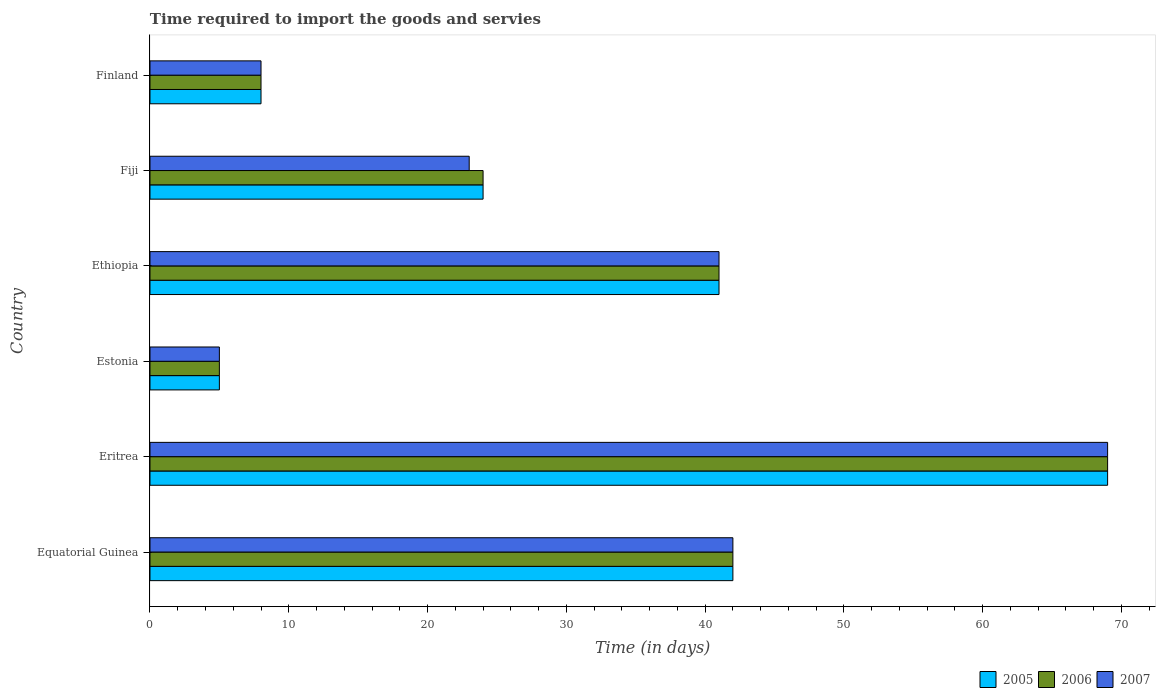How many different coloured bars are there?
Give a very brief answer. 3. Are the number of bars on each tick of the Y-axis equal?
Make the answer very short. Yes. How many bars are there on the 2nd tick from the top?
Your response must be concise. 3. What is the label of the 5th group of bars from the top?
Your answer should be very brief. Eritrea. In how many cases, is the number of bars for a given country not equal to the number of legend labels?
Offer a very short reply. 0. Across all countries, what is the maximum number of days required to import the goods and services in 2005?
Make the answer very short. 69. In which country was the number of days required to import the goods and services in 2005 maximum?
Provide a short and direct response. Eritrea. In which country was the number of days required to import the goods and services in 2006 minimum?
Offer a terse response. Estonia. What is the total number of days required to import the goods and services in 2005 in the graph?
Your answer should be very brief. 189. What is the difference between the number of days required to import the goods and services in 2006 in Equatorial Guinea and that in Estonia?
Ensure brevity in your answer.  37. What is the average number of days required to import the goods and services in 2007 per country?
Offer a terse response. 31.33. In how many countries, is the number of days required to import the goods and services in 2006 greater than 28 days?
Provide a short and direct response. 3. What is the ratio of the number of days required to import the goods and services in 2007 in Estonia to that in Ethiopia?
Make the answer very short. 0.12. Is the difference between the number of days required to import the goods and services in 2006 in Fiji and Finland greater than the difference between the number of days required to import the goods and services in 2005 in Fiji and Finland?
Your answer should be compact. No. What is the difference between the highest and the lowest number of days required to import the goods and services in 2005?
Your response must be concise. 64. In how many countries, is the number of days required to import the goods and services in 2005 greater than the average number of days required to import the goods and services in 2005 taken over all countries?
Ensure brevity in your answer.  3. Is the sum of the number of days required to import the goods and services in 2006 in Eritrea and Estonia greater than the maximum number of days required to import the goods and services in 2007 across all countries?
Provide a short and direct response. Yes. Are all the bars in the graph horizontal?
Your answer should be very brief. Yes. How many countries are there in the graph?
Offer a very short reply. 6. Are the values on the major ticks of X-axis written in scientific E-notation?
Give a very brief answer. No. How many legend labels are there?
Make the answer very short. 3. What is the title of the graph?
Make the answer very short. Time required to import the goods and servies. Does "1987" appear as one of the legend labels in the graph?
Ensure brevity in your answer.  No. What is the label or title of the X-axis?
Your answer should be very brief. Time (in days). What is the label or title of the Y-axis?
Keep it short and to the point. Country. What is the Time (in days) in 2005 in Equatorial Guinea?
Your response must be concise. 42. What is the Time (in days) in 2005 in Eritrea?
Offer a terse response. 69. What is the Time (in days) in 2007 in Eritrea?
Your answer should be very brief. 69. What is the Time (in days) in 2006 in Estonia?
Your response must be concise. 5. What is the Time (in days) in 2007 in Estonia?
Your response must be concise. 5. What is the Time (in days) in 2005 in Ethiopia?
Give a very brief answer. 41. What is the Time (in days) of 2005 in Fiji?
Provide a short and direct response. 24. What is the Time (in days) in 2006 in Fiji?
Offer a terse response. 24. What is the Time (in days) of 2007 in Fiji?
Make the answer very short. 23. What is the Time (in days) in 2005 in Finland?
Your response must be concise. 8. What is the Time (in days) in 2006 in Finland?
Your response must be concise. 8. What is the Time (in days) of 2007 in Finland?
Make the answer very short. 8. Across all countries, what is the maximum Time (in days) in 2005?
Make the answer very short. 69. Across all countries, what is the minimum Time (in days) in 2005?
Offer a terse response. 5. What is the total Time (in days) of 2005 in the graph?
Give a very brief answer. 189. What is the total Time (in days) in 2006 in the graph?
Make the answer very short. 189. What is the total Time (in days) of 2007 in the graph?
Provide a succinct answer. 188. What is the difference between the Time (in days) of 2006 in Equatorial Guinea and that in Eritrea?
Provide a succinct answer. -27. What is the difference between the Time (in days) of 2007 in Equatorial Guinea and that in Eritrea?
Make the answer very short. -27. What is the difference between the Time (in days) in 2005 in Equatorial Guinea and that in Estonia?
Give a very brief answer. 37. What is the difference between the Time (in days) of 2006 in Equatorial Guinea and that in Estonia?
Give a very brief answer. 37. What is the difference between the Time (in days) of 2005 in Equatorial Guinea and that in Finland?
Offer a terse response. 34. What is the difference between the Time (in days) in 2006 in Equatorial Guinea and that in Finland?
Ensure brevity in your answer.  34. What is the difference between the Time (in days) in 2007 in Equatorial Guinea and that in Finland?
Provide a succinct answer. 34. What is the difference between the Time (in days) in 2005 in Eritrea and that in Estonia?
Provide a short and direct response. 64. What is the difference between the Time (in days) of 2006 in Eritrea and that in Estonia?
Offer a terse response. 64. What is the difference between the Time (in days) in 2005 in Eritrea and that in Ethiopia?
Your response must be concise. 28. What is the difference between the Time (in days) of 2007 in Eritrea and that in Ethiopia?
Provide a succinct answer. 28. What is the difference between the Time (in days) in 2005 in Eritrea and that in Fiji?
Keep it short and to the point. 45. What is the difference between the Time (in days) of 2007 in Eritrea and that in Fiji?
Offer a terse response. 46. What is the difference between the Time (in days) of 2007 in Eritrea and that in Finland?
Your answer should be very brief. 61. What is the difference between the Time (in days) in 2005 in Estonia and that in Ethiopia?
Keep it short and to the point. -36. What is the difference between the Time (in days) of 2006 in Estonia and that in Ethiopia?
Make the answer very short. -36. What is the difference between the Time (in days) in 2007 in Estonia and that in Ethiopia?
Ensure brevity in your answer.  -36. What is the difference between the Time (in days) of 2005 in Estonia and that in Fiji?
Offer a terse response. -19. What is the difference between the Time (in days) in 2006 in Estonia and that in Fiji?
Your response must be concise. -19. What is the difference between the Time (in days) in 2007 in Estonia and that in Fiji?
Provide a short and direct response. -18. What is the difference between the Time (in days) of 2005 in Ethiopia and that in Fiji?
Your answer should be very brief. 17. What is the difference between the Time (in days) in 2006 in Ethiopia and that in Fiji?
Your answer should be very brief. 17. What is the difference between the Time (in days) of 2006 in Fiji and that in Finland?
Make the answer very short. 16. What is the difference between the Time (in days) of 2007 in Fiji and that in Finland?
Give a very brief answer. 15. What is the difference between the Time (in days) of 2006 in Equatorial Guinea and the Time (in days) of 2007 in Eritrea?
Provide a succinct answer. -27. What is the difference between the Time (in days) in 2005 in Equatorial Guinea and the Time (in days) in 2006 in Estonia?
Offer a very short reply. 37. What is the difference between the Time (in days) of 2005 in Equatorial Guinea and the Time (in days) of 2007 in Estonia?
Make the answer very short. 37. What is the difference between the Time (in days) in 2006 in Equatorial Guinea and the Time (in days) in 2007 in Estonia?
Keep it short and to the point. 37. What is the difference between the Time (in days) in 2005 in Equatorial Guinea and the Time (in days) in 2006 in Ethiopia?
Keep it short and to the point. 1. What is the difference between the Time (in days) of 2005 in Equatorial Guinea and the Time (in days) of 2007 in Fiji?
Ensure brevity in your answer.  19. What is the difference between the Time (in days) in 2005 in Equatorial Guinea and the Time (in days) in 2007 in Finland?
Provide a succinct answer. 34. What is the difference between the Time (in days) of 2006 in Equatorial Guinea and the Time (in days) of 2007 in Finland?
Offer a terse response. 34. What is the difference between the Time (in days) of 2005 in Eritrea and the Time (in days) of 2006 in Estonia?
Your response must be concise. 64. What is the difference between the Time (in days) of 2005 in Eritrea and the Time (in days) of 2007 in Estonia?
Your response must be concise. 64. What is the difference between the Time (in days) of 2006 in Eritrea and the Time (in days) of 2007 in Estonia?
Give a very brief answer. 64. What is the difference between the Time (in days) of 2005 in Eritrea and the Time (in days) of 2006 in Ethiopia?
Make the answer very short. 28. What is the difference between the Time (in days) in 2006 in Eritrea and the Time (in days) in 2007 in Ethiopia?
Give a very brief answer. 28. What is the difference between the Time (in days) in 2005 in Eritrea and the Time (in days) in 2006 in Fiji?
Your answer should be compact. 45. What is the difference between the Time (in days) of 2005 in Eritrea and the Time (in days) of 2007 in Fiji?
Your answer should be very brief. 46. What is the difference between the Time (in days) of 2006 in Eritrea and the Time (in days) of 2007 in Fiji?
Provide a succinct answer. 46. What is the difference between the Time (in days) of 2005 in Eritrea and the Time (in days) of 2007 in Finland?
Keep it short and to the point. 61. What is the difference between the Time (in days) in 2006 in Eritrea and the Time (in days) in 2007 in Finland?
Your answer should be compact. 61. What is the difference between the Time (in days) of 2005 in Estonia and the Time (in days) of 2006 in Ethiopia?
Offer a very short reply. -36. What is the difference between the Time (in days) in 2005 in Estonia and the Time (in days) in 2007 in Ethiopia?
Your answer should be compact. -36. What is the difference between the Time (in days) in 2006 in Estonia and the Time (in days) in 2007 in Ethiopia?
Make the answer very short. -36. What is the difference between the Time (in days) of 2005 in Estonia and the Time (in days) of 2007 in Fiji?
Your answer should be very brief. -18. What is the difference between the Time (in days) in 2006 in Estonia and the Time (in days) in 2007 in Fiji?
Make the answer very short. -18. What is the difference between the Time (in days) of 2005 in Estonia and the Time (in days) of 2007 in Finland?
Ensure brevity in your answer.  -3. What is the difference between the Time (in days) in 2006 in Ethiopia and the Time (in days) in 2007 in Fiji?
Your response must be concise. 18. What is the difference between the Time (in days) in 2005 in Ethiopia and the Time (in days) in 2006 in Finland?
Ensure brevity in your answer.  33. What is the difference between the Time (in days) of 2005 in Ethiopia and the Time (in days) of 2007 in Finland?
Ensure brevity in your answer.  33. What is the difference between the Time (in days) in 2005 in Fiji and the Time (in days) in 2007 in Finland?
Give a very brief answer. 16. What is the difference between the Time (in days) of 2006 in Fiji and the Time (in days) of 2007 in Finland?
Your answer should be compact. 16. What is the average Time (in days) in 2005 per country?
Offer a terse response. 31.5. What is the average Time (in days) in 2006 per country?
Your response must be concise. 31.5. What is the average Time (in days) in 2007 per country?
Your response must be concise. 31.33. What is the difference between the Time (in days) of 2005 and Time (in days) of 2006 in Equatorial Guinea?
Make the answer very short. 0. What is the difference between the Time (in days) in 2006 and Time (in days) in 2007 in Equatorial Guinea?
Provide a succinct answer. 0. What is the difference between the Time (in days) in 2005 and Time (in days) in 2007 in Eritrea?
Provide a succinct answer. 0. What is the difference between the Time (in days) in 2005 and Time (in days) in 2007 in Estonia?
Your answer should be compact. 0. What is the difference between the Time (in days) in 2006 and Time (in days) in 2007 in Estonia?
Ensure brevity in your answer.  0. What is the difference between the Time (in days) of 2005 and Time (in days) of 2006 in Ethiopia?
Give a very brief answer. 0. What is the difference between the Time (in days) of 2005 and Time (in days) of 2007 in Ethiopia?
Provide a succinct answer. 0. What is the difference between the Time (in days) in 2006 and Time (in days) in 2007 in Ethiopia?
Your answer should be compact. 0. What is the difference between the Time (in days) in 2005 and Time (in days) in 2006 in Fiji?
Offer a terse response. 0. What is the difference between the Time (in days) in 2006 and Time (in days) in 2007 in Fiji?
Keep it short and to the point. 1. What is the ratio of the Time (in days) of 2005 in Equatorial Guinea to that in Eritrea?
Ensure brevity in your answer.  0.61. What is the ratio of the Time (in days) in 2006 in Equatorial Guinea to that in Eritrea?
Your answer should be compact. 0.61. What is the ratio of the Time (in days) in 2007 in Equatorial Guinea to that in Eritrea?
Offer a very short reply. 0.61. What is the ratio of the Time (in days) of 2005 in Equatorial Guinea to that in Ethiopia?
Your answer should be very brief. 1.02. What is the ratio of the Time (in days) in 2006 in Equatorial Guinea to that in Ethiopia?
Your response must be concise. 1.02. What is the ratio of the Time (in days) of 2007 in Equatorial Guinea to that in Ethiopia?
Keep it short and to the point. 1.02. What is the ratio of the Time (in days) in 2005 in Equatorial Guinea to that in Fiji?
Keep it short and to the point. 1.75. What is the ratio of the Time (in days) in 2007 in Equatorial Guinea to that in Fiji?
Offer a terse response. 1.83. What is the ratio of the Time (in days) in 2005 in Equatorial Guinea to that in Finland?
Offer a very short reply. 5.25. What is the ratio of the Time (in days) of 2006 in Equatorial Guinea to that in Finland?
Keep it short and to the point. 5.25. What is the ratio of the Time (in days) of 2007 in Equatorial Guinea to that in Finland?
Provide a short and direct response. 5.25. What is the ratio of the Time (in days) in 2005 in Eritrea to that in Estonia?
Make the answer very short. 13.8. What is the ratio of the Time (in days) in 2006 in Eritrea to that in Estonia?
Make the answer very short. 13.8. What is the ratio of the Time (in days) in 2007 in Eritrea to that in Estonia?
Provide a short and direct response. 13.8. What is the ratio of the Time (in days) in 2005 in Eritrea to that in Ethiopia?
Your answer should be very brief. 1.68. What is the ratio of the Time (in days) of 2006 in Eritrea to that in Ethiopia?
Ensure brevity in your answer.  1.68. What is the ratio of the Time (in days) of 2007 in Eritrea to that in Ethiopia?
Your answer should be compact. 1.68. What is the ratio of the Time (in days) in 2005 in Eritrea to that in Fiji?
Provide a short and direct response. 2.88. What is the ratio of the Time (in days) in 2006 in Eritrea to that in Fiji?
Keep it short and to the point. 2.88. What is the ratio of the Time (in days) of 2007 in Eritrea to that in Fiji?
Ensure brevity in your answer.  3. What is the ratio of the Time (in days) of 2005 in Eritrea to that in Finland?
Your answer should be very brief. 8.62. What is the ratio of the Time (in days) in 2006 in Eritrea to that in Finland?
Offer a terse response. 8.62. What is the ratio of the Time (in days) in 2007 in Eritrea to that in Finland?
Provide a short and direct response. 8.62. What is the ratio of the Time (in days) of 2005 in Estonia to that in Ethiopia?
Offer a terse response. 0.12. What is the ratio of the Time (in days) of 2006 in Estonia to that in Ethiopia?
Offer a very short reply. 0.12. What is the ratio of the Time (in days) of 2007 in Estonia to that in Ethiopia?
Your response must be concise. 0.12. What is the ratio of the Time (in days) in 2005 in Estonia to that in Fiji?
Make the answer very short. 0.21. What is the ratio of the Time (in days) in 2006 in Estonia to that in Fiji?
Your answer should be very brief. 0.21. What is the ratio of the Time (in days) of 2007 in Estonia to that in Fiji?
Make the answer very short. 0.22. What is the ratio of the Time (in days) of 2007 in Estonia to that in Finland?
Your answer should be compact. 0.62. What is the ratio of the Time (in days) in 2005 in Ethiopia to that in Fiji?
Your answer should be compact. 1.71. What is the ratio of the Time (in days) in 2006 in Ethiopia to that in Fiji?
Keep it short and to the point. 1.71. What is the ratio of the Time (in days) of 2007 in Ethiopia to that in Fiji?
Ensure brevity in your answer.  1.78. What is the ratio of the Time (in days) of 2005 in Ethiopia to that in Finland?
Ensure brevity in your answer.  5.12. What is the ratio of the Time (in days) in 2006 in Ethiopia to that in Finland?
Provide a short and direct response. 5.12. What is the ratio of the Time (in days) of 2007 in Ethiopia to that in Finland?
Your answer should be compact. 5.12. What is the ratio of the Time (in days) of 2005 in Fiji to that in Finland?
Your response must be concise. 3. What is the ratio of the Time (in days) of 2007 in Fiji to that in Finland?
Your answer should be compact. 2.88. What is the difference between the highest and the second highest Time (in days) of 2007?
Give a very brief answer. 27. What is the difference between the highest and the lowest Time (in days) in 2005?
Give a very brief answer. 64. What is the difference between the highest and the lowest Time (in days) of 2007?
Your answer should be very brief. 64. 